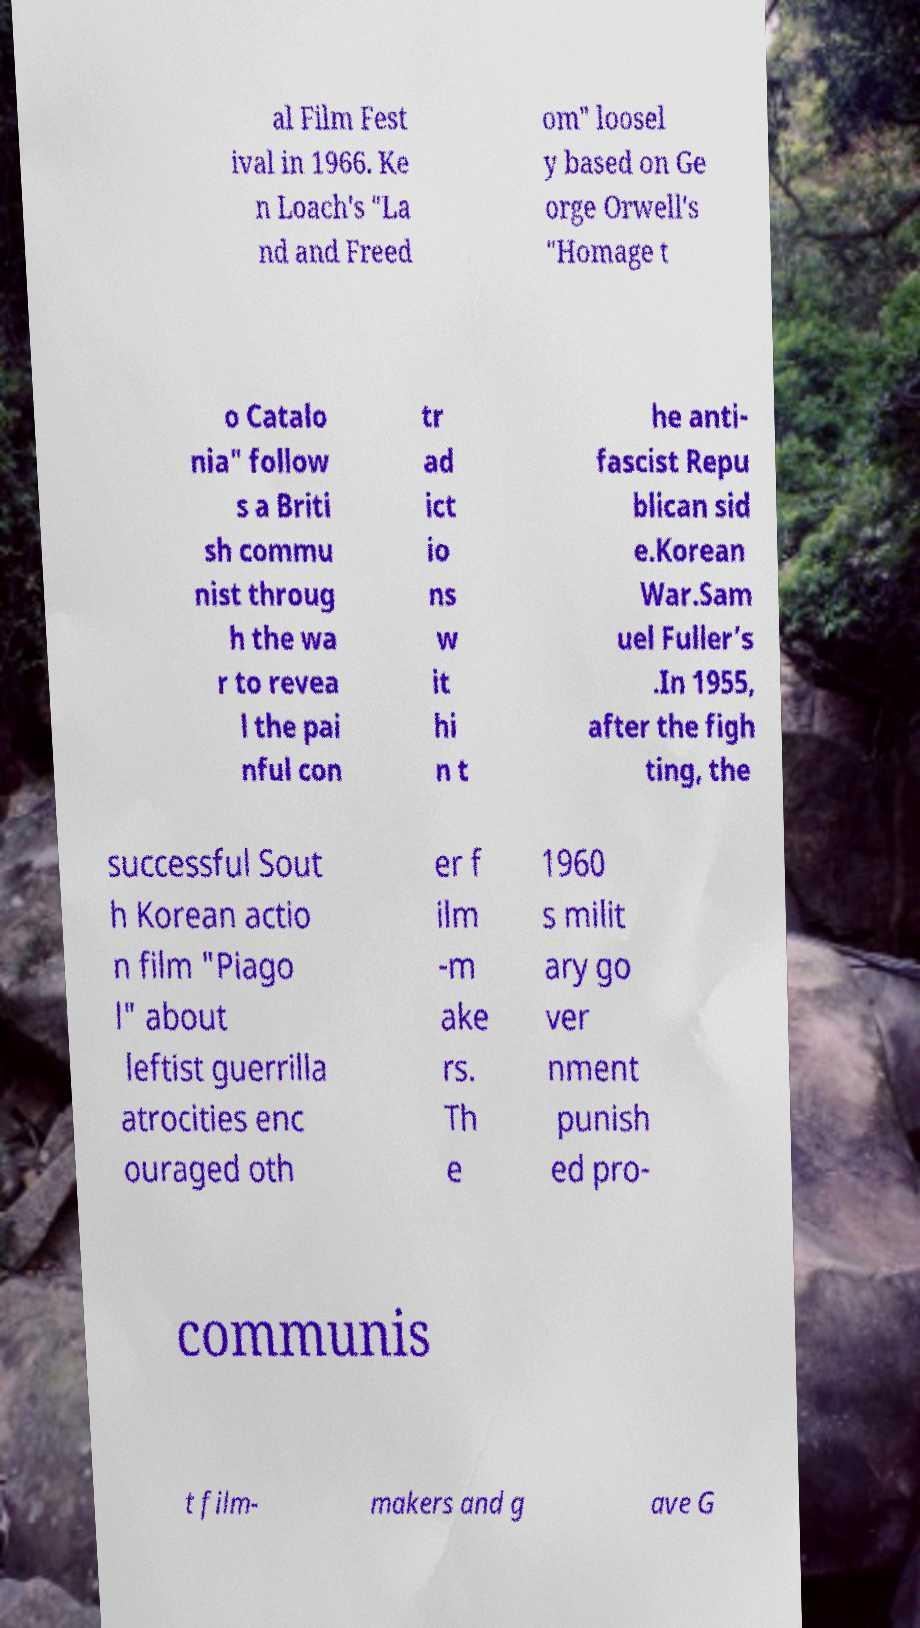There's text embedded in this image that I need extracted. Can you transcribe it verbatim? al Film Fest ival in 1966. Ke n Loach's "La nd and Freed om" loosel y based on Ge orge Orwell's "Homage t o Catalo nia" follow s a Briti sh commu nist throug h the wa r to revea l the pai nful con tr ad ict io ns w it hi n t he anti- fascist Repu blican sid e.Korean War.Sam uel Fuller’s .In 1955, after the figh ting, the successful Sout h Korean actio n film "Piago l" about leftist guerrilla atrocities enc ouraged oth er f ilm -m ake rs. Th e 1960 s milit ary go ver nment punish ed pro- communis t film- makers and g ave G 